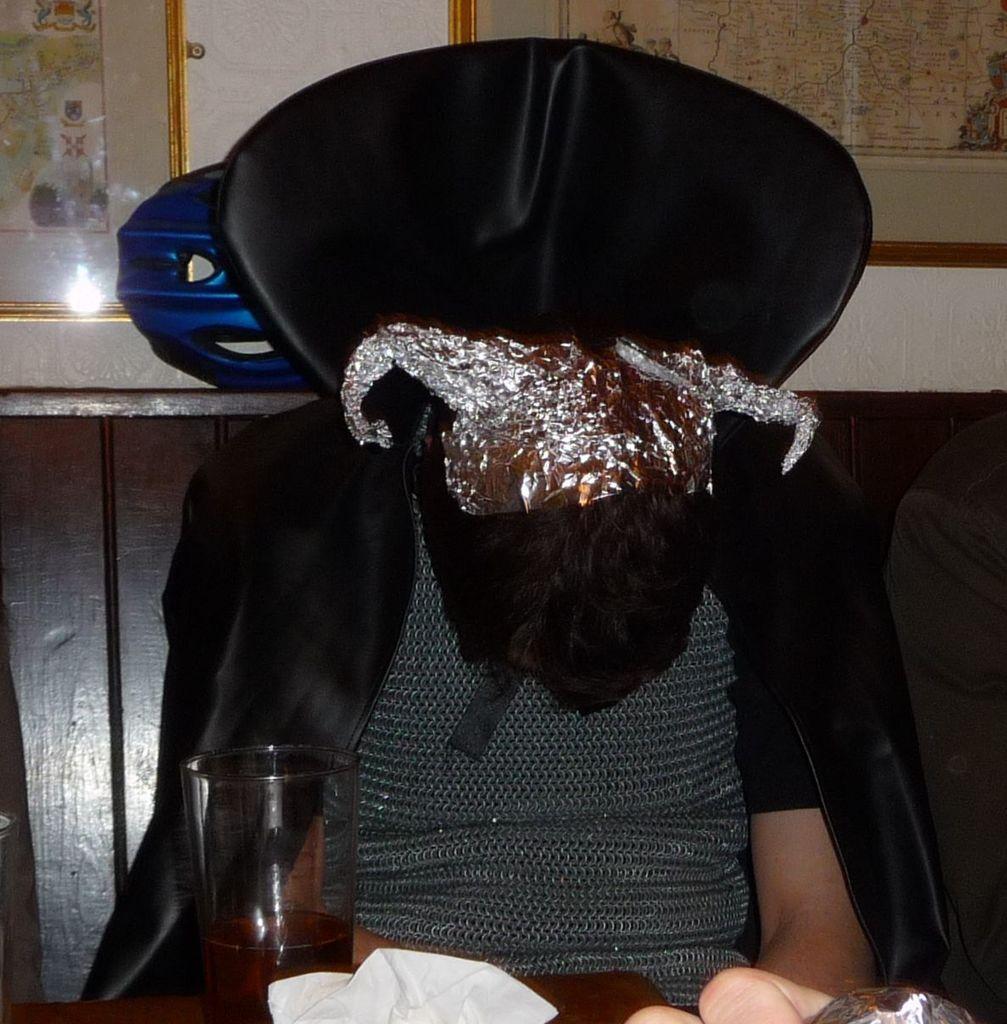In one or two sentences, can you explain what this image depicts? In this image we can see there is a person sitting on a chair, he is wearing a mask, in front there is a table, glass and some objects on it, at the back there are photo frames on a wall. 